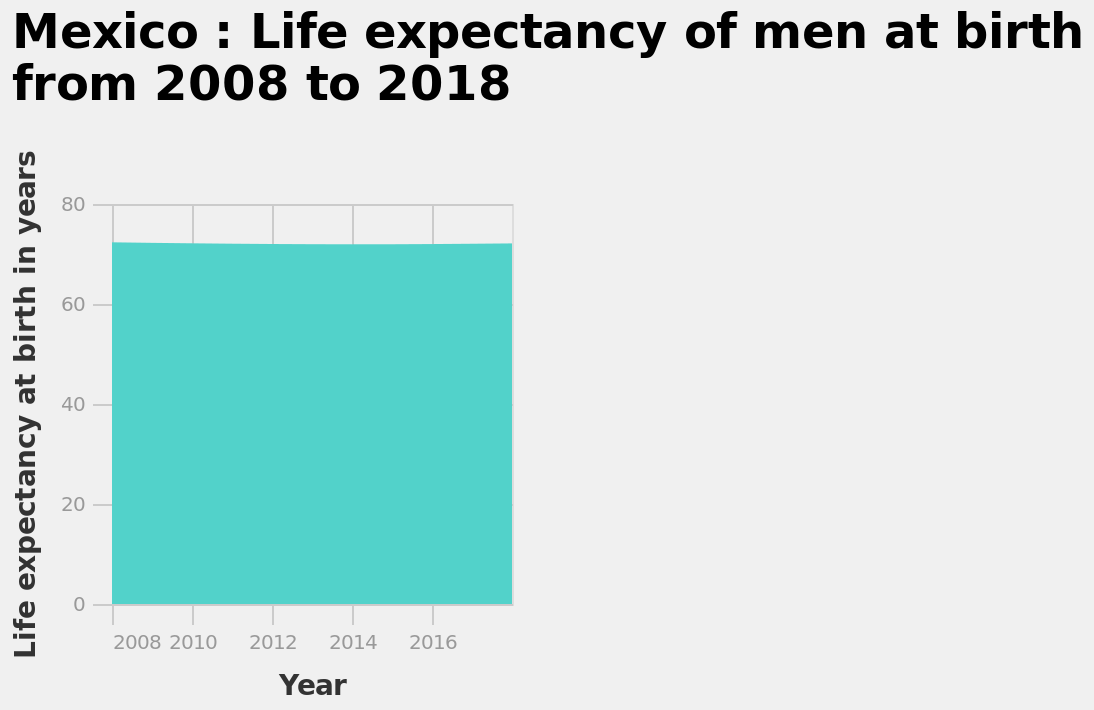<image>
Do males born between 2008 and 2018 have different life expectancies? No, males born between 2008 and 2018 have the same life expectancy. Are there any variations in life expectancy among males born between 2008 and 2018? No, there are no variations in life expectancy among males born between 2008 and 2018. 